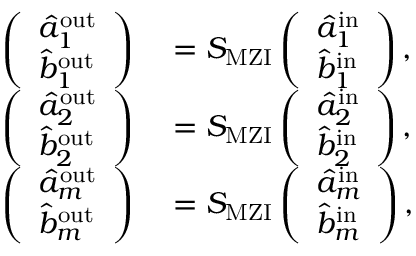Convert formula to latex. <formula><loc_0><loc_0><loc_500><loc_500>\begin{array} { r l } { \left ( \begin{array} { l } { \hat { a } _ { 1 } ^ { o u t } } \\ { \hat { b } _ { 1 } ^ { o u t } } \end{array} \right ) } & = S _ { M Z I } \left ( \begin{array} { l } { \hat { a } _ { 1 } ^ { i n } } \\ { \hat { b } _ { 1 } ^ { i n } } \end{array} \right ) , } \\ { \left ( \begin{array} { l } { \hat { a } _ { 2 } ^ { o u t } } \\ { \hat { b } _ { 2 } ^ { o u t } } \end{array} \right ) } & = S _ { M Z I } \left ( \begin{array} { l } { \hat { a } _ { 2 } ^ { i n } } \\ { \hat { b } _ { 2 } ^ { i n } } \end{array} \right ) , } \\ { \left ( \begin{array} { l } { \hat { a } _ { m } ^ { o u t } } \\ { \hat { b } _ { m } ^ { o u t } } \end{array} \right ) } & = S _ { M Z I } \left ( \begin{array} { l } { \hat { a } _ { m } ^ { i n } } \\ { \hat { b } _ { m } ^ { i n } } \end{array} \right ) , } \end{array}</formula> 